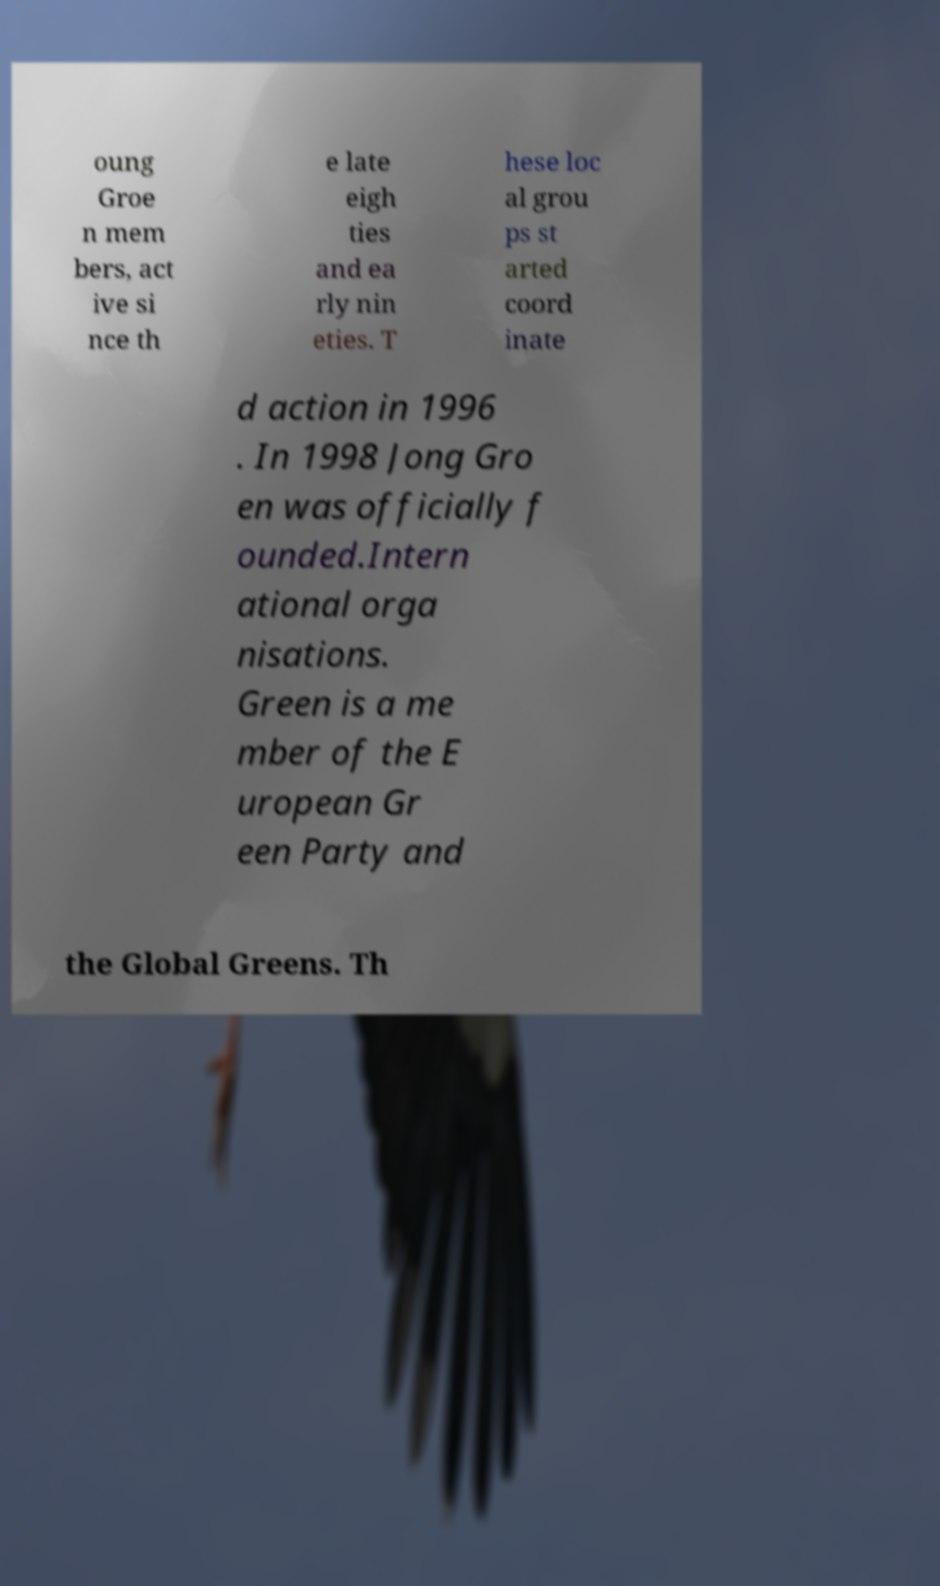Could you assist in decoding the text presented in this image and type it out clearly? oung Groe n mem bers, act ive si nce th e late eigh ties and ea rly nin eties. T hese loc al grou ps st arted coord inate d action in 1996 . In 1998 Jong Gro en was officially f ounded.Intern ational orga nisations. Green is a me mber of the E uropean Gr een Party and the Global Greens. Th 